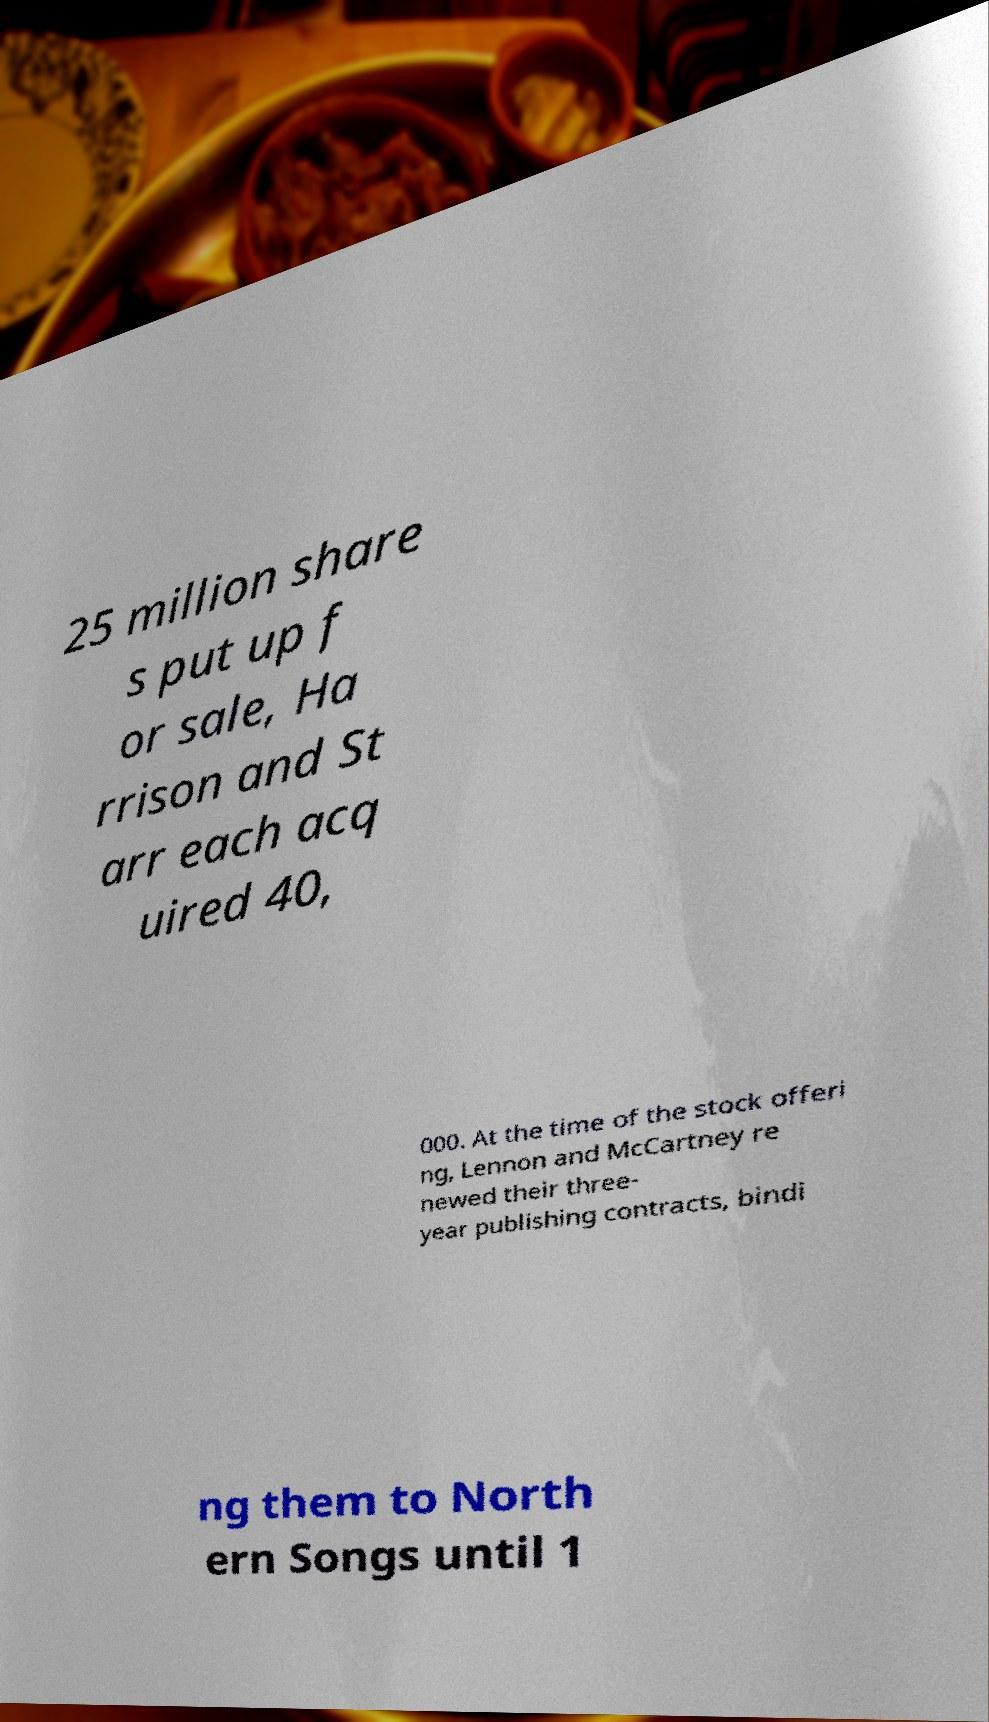What messages or text are displayed in this image? I need them in a readable, typed format. 25 million share s put up f or sale, Ha rrison and St arr each acq uired 40, 000. At the time of the stock offeri ng, Lennon and McCartney re newed their three- year publishing contracts, bindi ng them to North ern Songs until 1 